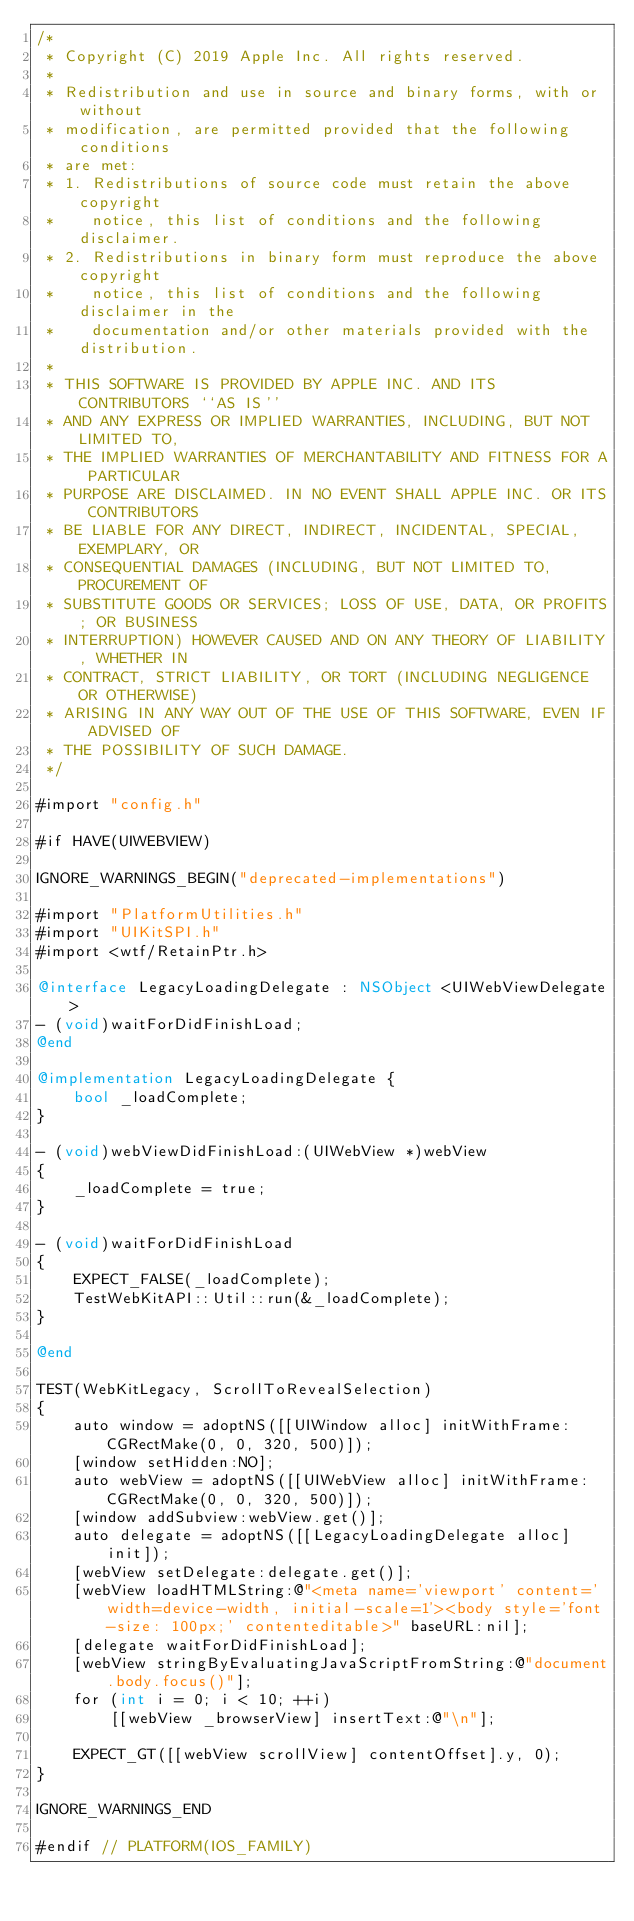<code> <loc_0><loc_0><loc_500><loc_500><_ObjectiveC_>/*
 * Copyright (C) 2019 Apple Inc. All rights reserved.
 *
 * Redistribution and use in source and binary forms, with or without
 * modification, are permitted provided that the following conditions
 * are met:
 * 1. Redistributions of source code must retain the above copyright
 *    notice, this list of conditions and the following disclaimer.
 * 2. Redistributions in binary form must reproduce the above copyright
 *    notice, this list of conditions and the following disclaimer in the
 *    documentation and/or other materials provided with the distribution.
 *
 * THIS SOFTWARE IS PROVIDED BY APPLE INC. AND ITS CONTRIBUTORS ``AS IS''
 * AND ANY EXPRESS OR IMPLIED WARRANTIES, INCLUDING, BUT NOT LIMITED TO,
 * THE IMPLIED WARRANTIES OF MERCHANTABILITY AND FITNESS FOR A PARTICULAR
 * PURPOSE ARE DISCLAIMED. IN NO EVENT SHALL APPLE INC. OR ITS CONTRIBUTORS
 * BE LIABLE FOR ANY DIRECT, INDIRECT, INCIDENTAL, SPECIAL, EXEMPLARY, OR
 * CONSEQUENTIAL DAMAGES (INCLUDING, BUT NOT LIMITED TO, PROCUREMENT OF
 * SUBSTITUTE GOODS OR SERVICES; LOSS OF USE, DATA, OR PROFITS; OR BUSINESS
 * INTERRUPTION) HOWEVER CAUSED AND ON ANY THEORY OF LIABILITY, WHETHER IN
 * CONTRACT, STRICT LIABILITY, OR TORT (INCLUDING NEGLIGENCE OR OTHERWISE)
 * ARISING IN ANY WAY OUT OF THE USE OF THIS SOFTWARE, EVEN IF ADVISED OF
 * THE POSSIBILITY OF SUCH DAMAGE.
 */

#import "config.h"

#if HAVE(UIWEBVIEW)

IGNORE_WARNINGS_BEGIN("deprecated-implementations")

#import "PlatformUtilities.h"
#import "UIKitSPI.h"
#import <wtf/RetainPtr.h>

@interface LegacyLoadingDelegate : NSObject <UIWebViewDelegate>
- (void)waitForDidFinishLoad;
@end

@implementation LegacyLoadingDelegate {
    bool _loadComplete;
}

- (void)webViewDidFinishLoad:(UIWebView *)webView
{
    _loadComplete = true;
}

- (void)waitForDidFinishLoad
{
    EXPECT_FALSE(_loadComplete);
    TestWebKitAPI::Util::run(&_loadComplete);
}

@end

TEST(WebKitLegacy, ScrollToRevealSelection)
{
    auto window = adoptNS([[UIWindow alloc] initWithFrame:CGRectMake(0, 0, 320, 500)]);
    [window setHidden:NO];
    auto webView = adoptNS([[UIWebView alloc] initWithFrame:CGRectMake(0, 0, 320, 500)]);
    [window addSubview:webView.get()];
    auto delegate = adoptNS([[LegacyLoadingDelegate alloc] init]);
    [webView setDelegate:delegate.get()];
    [webView loadHTMLString:@"<meta name='viewport' content='width=device-width, initial-scale=1'><body style='font-size: 100px;' contenteditable>" baseURL:nil];
    [delegate waitForDidFinishLoad];
    [webView stringByEvaluatingJavaScriptFromString:@"document.body.focus()"];
    for (int i = 0; i < 10; ++i)
        [[webView _browserView] insertText:@"\n"];

    EXPECT_GT([[webView scrollView] contentOffset].y, 0);
}

IGNORE_WARNINGS_END

#endif // PLATFORM(IOS_FAMILY)
</code> 